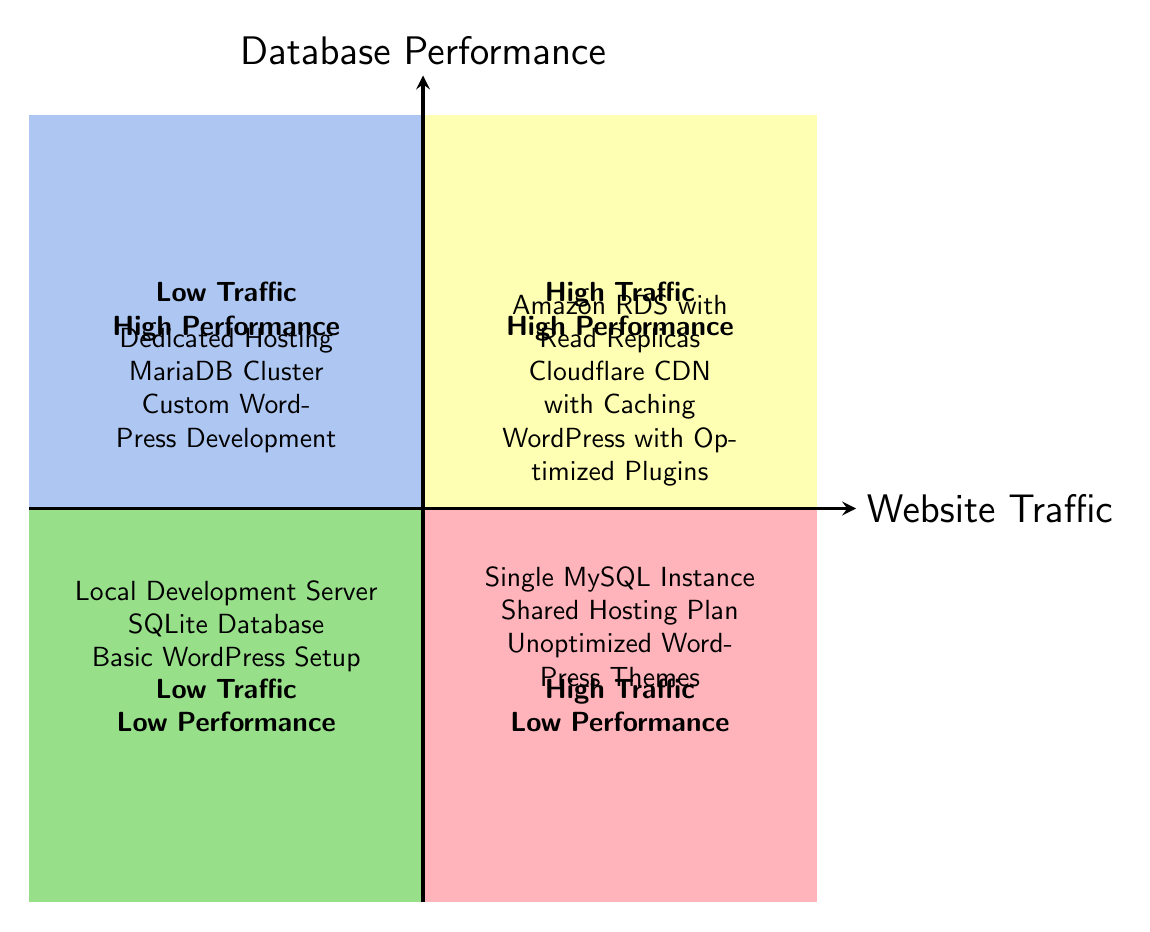What is placed in the High Traffic - High Performance quadrant? The High Traffic - High Performance quadrant contains data points that showcase optimal performance during peak website traffic. In this quadrant, the items listed are Amazon RDS with Read Replicas, Cloudflare CDN with Caching, and WordPress with Optimized Plugins.
Answer: Amazon RDS with Read Replicas, Cloudflare CDN with Caching, WordPress with Optimized Plugins How many data points are listed in the Low Traffic - Low Performance quadrant? The Low Traffic - Low Performance quadrant contains three entries: Local Development Server, SQLite Database, and Basic WordPress Setup. To find the answer, I simply counted the listed items in that quadrant.
Answer: 3 Which two quadrants highlight a high performance? The two quadrants that highlight high performance are the Low Traffic - High Performance quadrant and the High Traffic - High Performance quadrant. Identifying the performance levels and their traffic conditions led to this conclusion.
Answer: Low Traffic - High Performance, High Traffic - High Performance What is a key characteristic of the High Traffic - Low Performance quadrant? The High Traffic - Low Performance quadrant contains entries that suggest inadequately performing systems under heavy traffic. This includes a Single MySQL Instance, Shared Hosting Plan, and Unoptimized WordPress Themes, showing a clear lack of efficient structures in high traffic.
Answer: Inefficient structures under heavy traffic Which database should you choose for High Performance with Low Traffic? In the Low Traffic - High Performance quadrant, the recommended databases are Dedicated Hosting, MariaDB Cluster, and Custom WordPress Development, indicating their suitability for maintaining performance when traffic is low.
Answer: Dedicated Hosting, MariaDB Cluster, Custom WordPress Development Are there any database configurations listed in both Low Traffic quadrants? The diagram shows that there are no overlapping configurations in the Low Traffic quadrants, as each quadrant features distinct setups. The Low Traffic - High Performance quadrant includes Dedicated Hosting, MariaDB Cluster, and Custom WordPress Development, while the Low Traffic - Low Performance quadrant contains completely different entries.
Answer: No 